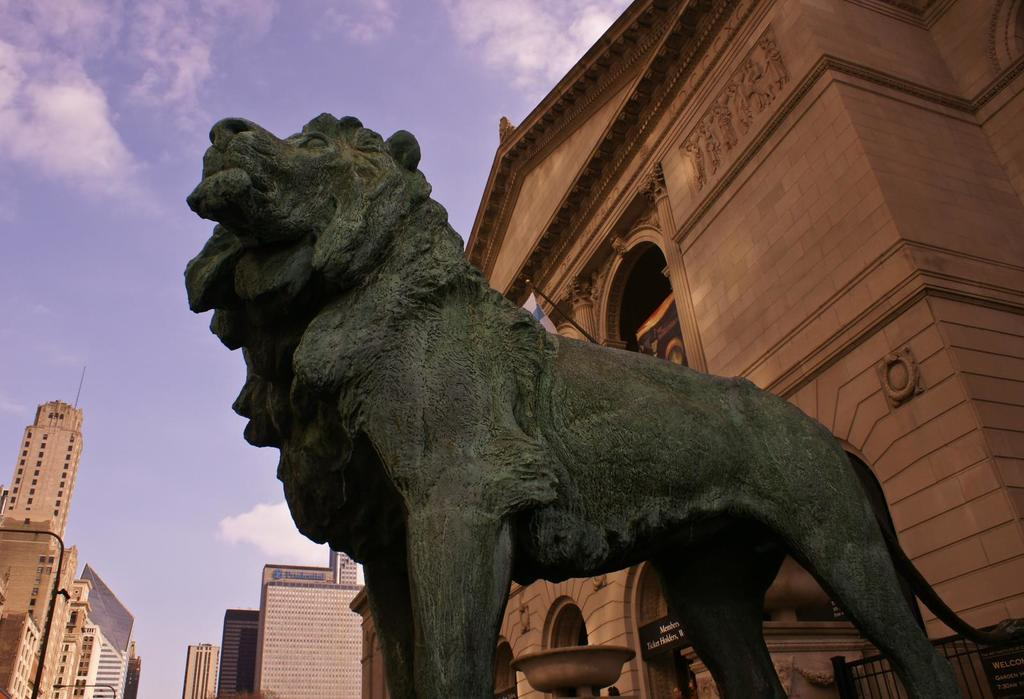What type of object is the main subject in the image? There is an animal statue in the image. What can be seen in the distance behind the animal statue? There are buildings and a fence in the background of the image. How would you describe the sky in the image? The sky is cloudy in the image. What type of alarm is attached to the animal statue in the image? There is no alarm present in the image; it is an animal statue without any additional features. 